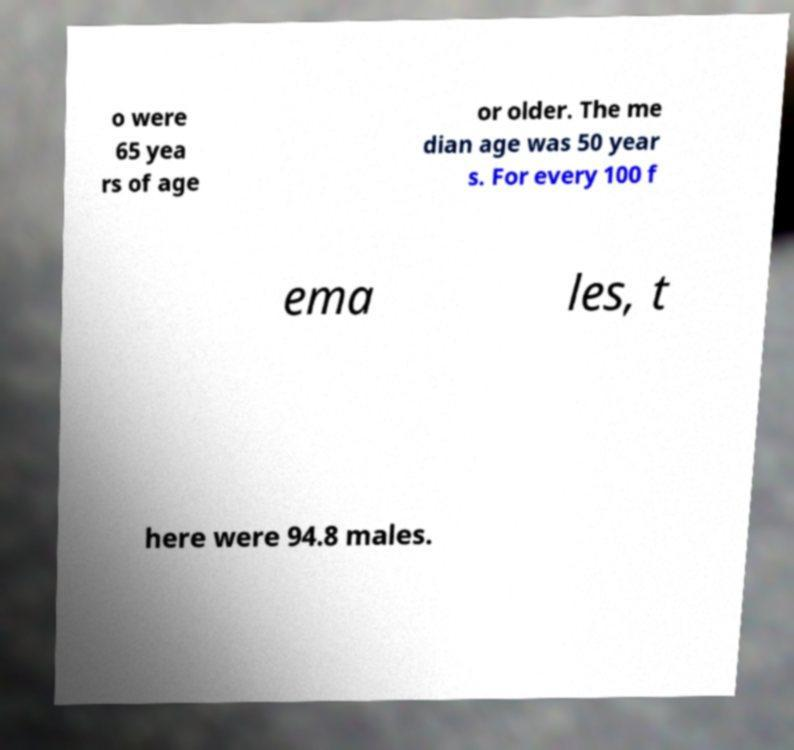For documentation purposes, I need the text within this image transcribed. Could you provide that? o were 65 yea rs of age or older. The me dian age was 50 year s. For every 100 f ema les, t here were 94.8 males. 